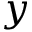<formula> <loc_0><loc_0><loc_500><loc_500>y</formula> 